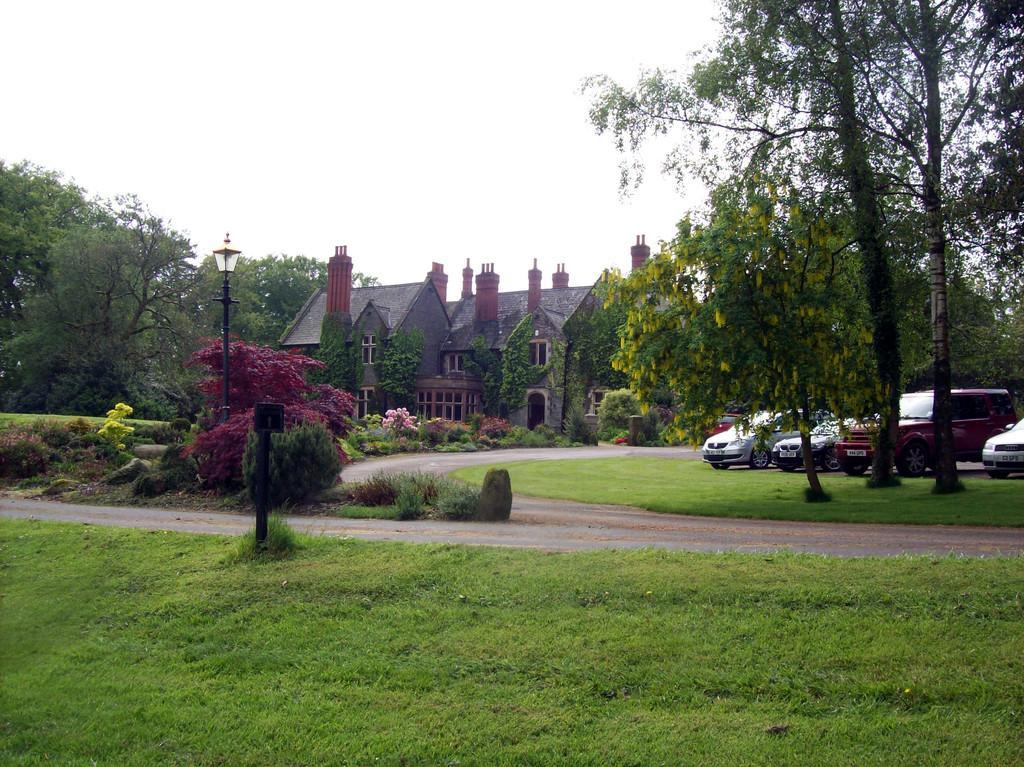Can you describe this image briefly? In this image we can see one house, some plants with flowers in front of the house, some cars parked on the ground, one light with pole, one small black board with pole, two roads, some trees, bushes, plants and green grass on the ground. At the top there is the sky. 